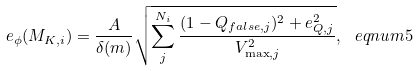Convert formula to latex. <formula><loc_0><loc_0><loc_500><loc_500>e _ { \phi } ( M _ { K , i } ) = \frac { A } { \delta ( m ) } \sqrt { \sum _ { j } ^ { N _ { i } } \frac { ( 1 - Q _ { f a l s e , j } ) ^ { 2 } + e _ { Q , j } ^ { 2 } } { V _ { \max , j } ^ { 2 } } } , \ e q n u m { 5 }</formula> 